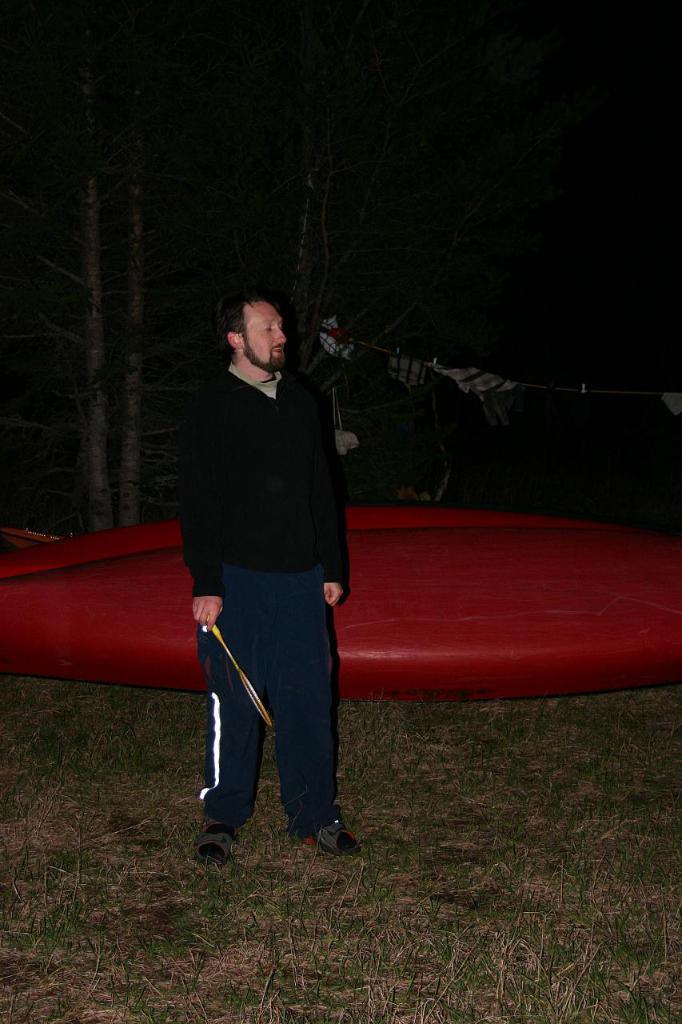Could you give a brief overview of what you see in this image? This picture is taken in the dark where we can see a person wearing black color jacket is holding the badminton racket and standing on the ground. Here we can see the grass and a blue color object. The background of the image is dark. 